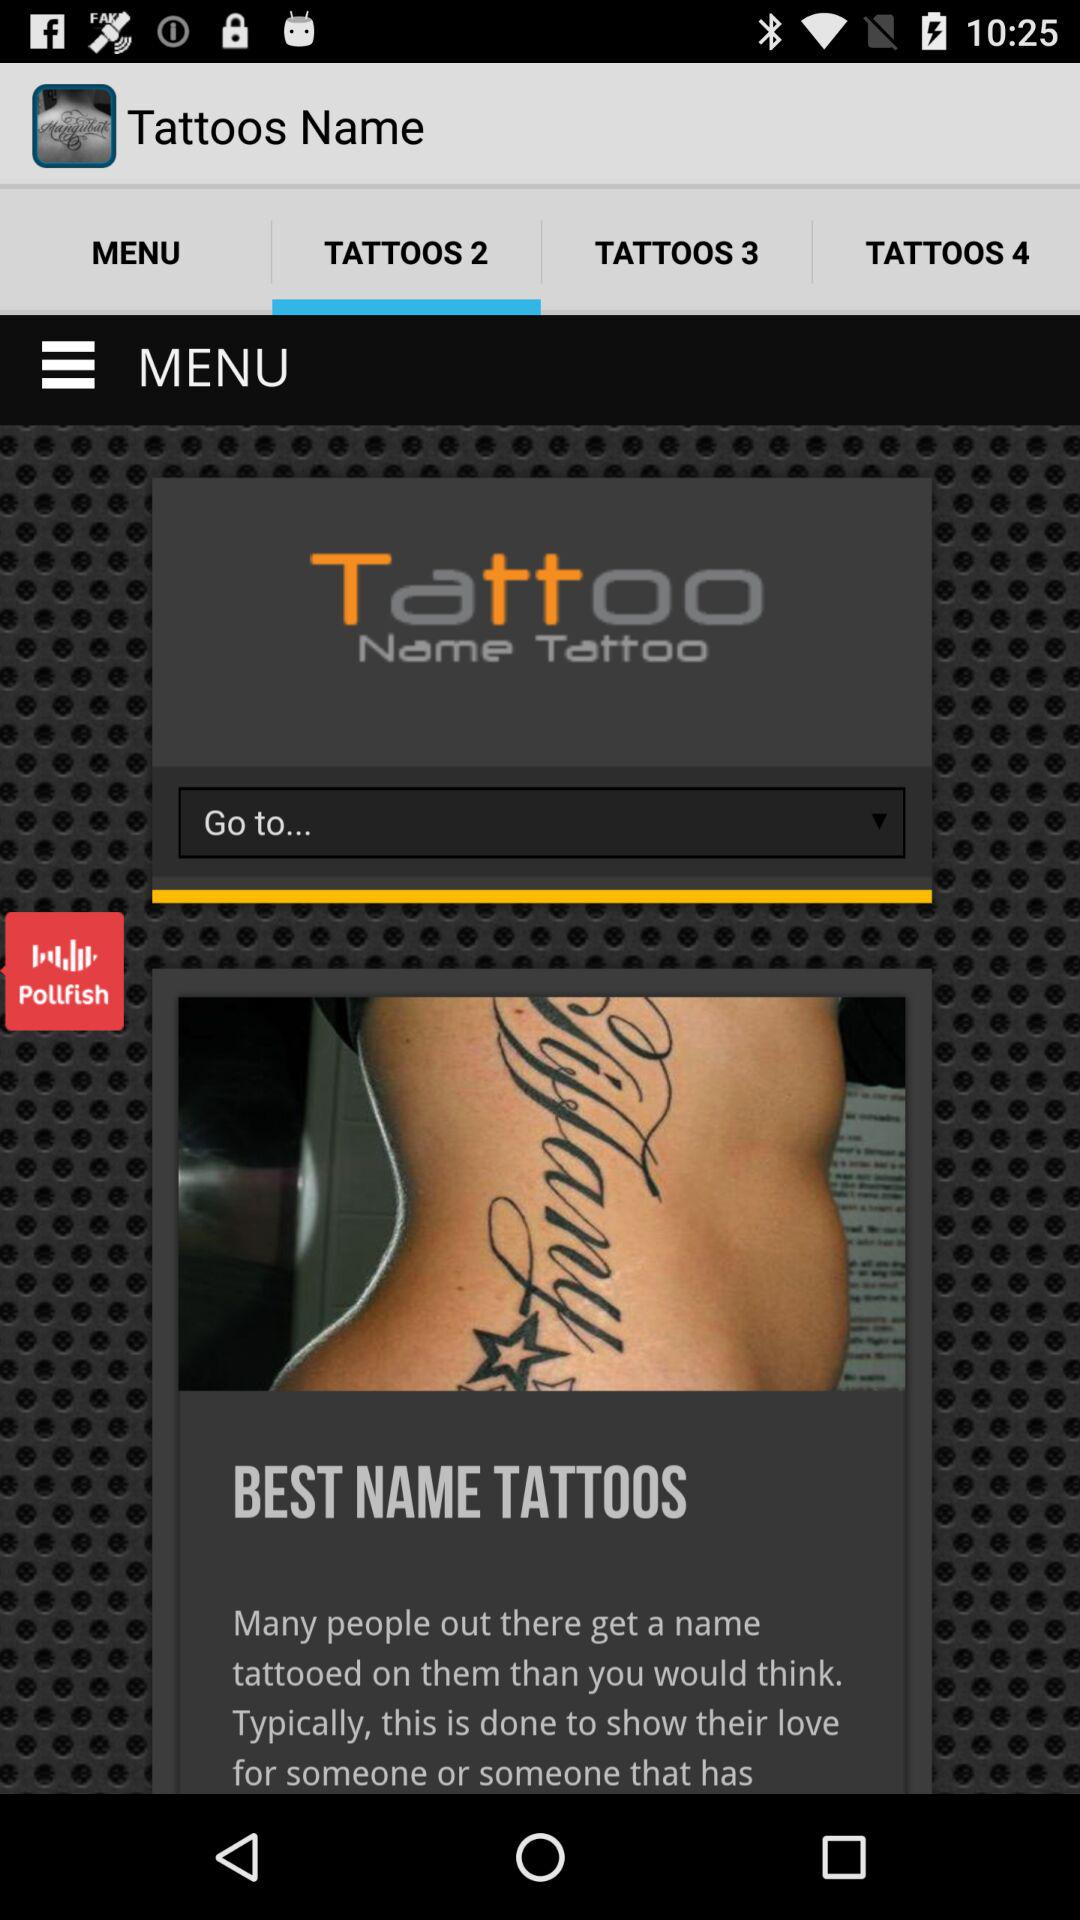What is the application name? The application name is "Tattoos Name". 